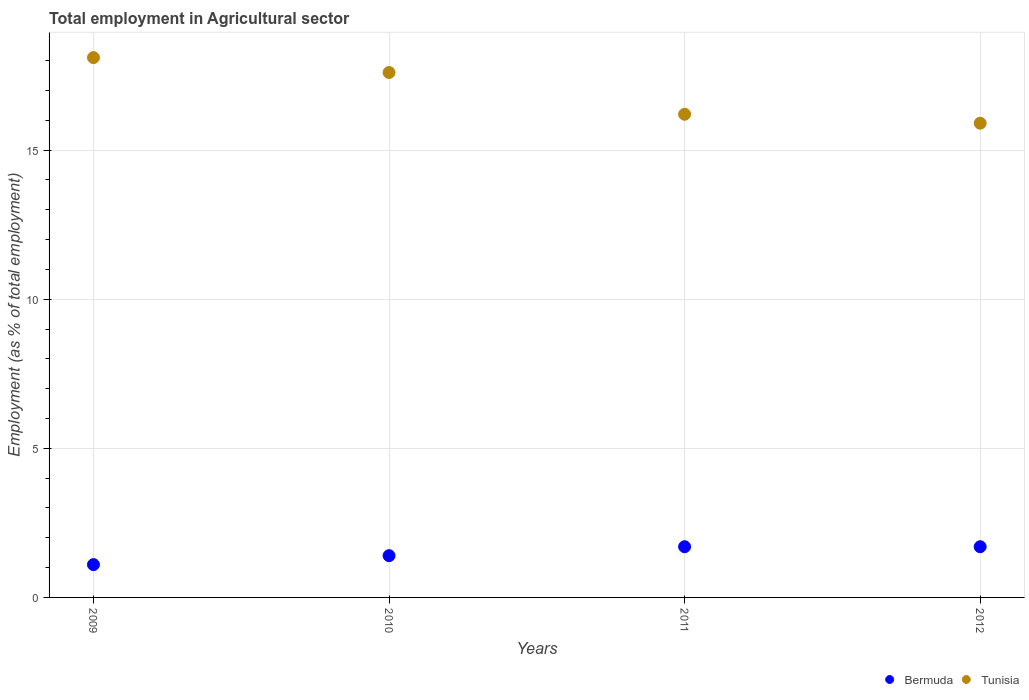How many different coloured dotlines are there?
Provide a short and direct response. 2. Is the number of dotlines equal to the number of legend labels?
Provide a succinct answer. Yes. What is the employment in agricultural sector in Bermuda in 2012?
Offer a very short reply. 1.7. Across all years, what is the maximum employment in agricultural sector in Bermuda?
Give a very brief answer. 1.7. Across all years, what is the minimum employment in agricultural sector in Bermuda?
Your answer should be very brief. 1.1. In which year was the employment in agricultural sector in Bermuda maximum?
Make the answer very short. 2011. What is the total employment in agricultural sector in Bermuda in the graph?
Provide a short and direct response. 5.9. What is the difference between the employment in agricultural sector in Bermuda in 2009 and that in 2010?
Give a very brief answer. -0.3. What is the difference between the employment in agricultural sector in Tunisia in 2011 and the employment in agricultural sector in Bermuda in 2009?
Ensure brevity in your answer.  15.1. What is the average employment in agricultural sector in Bermuda per year?
Provide a succinct answer. 1.48. In the year 2009, what is the difference between the employment in agricultural sector in Tunisia and employment in agricultural sector in Bermuda?
Provide a succinct answer. 17. In how many years, is the employment in agricultural sector in Bermuda greater than 11 %?
Keep it short and to the point. 0. What is the ratio of the employment in agricultural sector in Bermuda in 2009 to that in 2012?
Your answer should be compact. 0.65. Is the employment in agricultural sector in Bermuda in 2009 less than that in 2011?
Your answer should be very brief. Yes. What is the difference between the highest and the lowest employment in agricultural sector in Bermuda?
Your answer should be compact. 0.6. Does the employment in agricultural sector in Bermuda monotonically increase over the years?
Make the answer very short. No. How many dotlines are there?
Provide a succinct answer. 2. How many years are there in the graph?
Ensure brevity in your answer.  4. Where does the legend appear in the graph?
Provide a short and direct response. Bottom right. What is the title of the graph?
Your response must be concise. Total employment in Agricultural sector. Does "Paraguay" appear as one of the legend labels in the graph?
Ensure brevity in your answer.  No. What is the label or title of the X-axis?
Your answer should be compact. Years. What is the label or title of the Y-axis?
Ensure brevity in your answer.  Employment (as % of total employment). What is the Employment (as % of total employment) of Bermuda in 2009?
Your answer should be compact. 1.1. What is the Employment (as % of total employment) in Tunisia in 2009?
Your answer should be very brief. 18.1. What is the Employment (as % of total employment) of Bermuda in 2010?
Provide a succinct answer. 1.4. What is the Employment (as % of total employment) in Tunisia in 2010?
Give a very brief answer. 17.6. What is the Employment (as % of total employment) of Bermuda in 2011?
Offer a very short reply. 1.7. What is the Employment (as % of total employment) in Tunisia in 2011?
Give a very brief answer. 16.2. What is the Employment (as % of total employment) in Bermuda in 2012?
Ensure brevity in your answer.  1.7. What is the Employment (as % of total employment) of Tunisia in 2012?
Offer a very short reply. 15.9. Across all years, what is the maximum Employment (as % of total employment) in Bermuda?
Offer a very short reply. 1.7. Across all years, what is the maximum Employment (as % of total employment) in Tunisia?
Keep it short and to the point. 18.1. Across all years, what is the minimum Employment (as % of total employment) in Bermuda?
Offer a terse response. 1.1. Across all years, what is the minimum Employment (as % of total employment) of Tunisia?
Your response must be concise. 15.9. What is the total Employment (as % of total employment) of Bermuda in the graph?
Keep it short and to the point. 5.9. What is the total Employment (as % of total employment) of Tunisia in the graph?
Keep it short and to the point. 67.8. What is the difference between the Employment (as % of total employment) in Tunisia in 2009 and that in 2010?
Provide a short and direct response. 0.5. What is the difference between the Employment (as % of total employment) of Bermuda in 2009 and that in 2011?
Your answer should be very brief. -0.6. What is the difference between the Employment (as % of total employment) of Tunisia in 2009 and that in 2011?
Your answer should be compact. 1.9. What is the difference between the Employment (as % of total employment) in Tunisia in 2009 and that in 2012?
Your response must be concise. 2.2. What is the difference between the Employment (as % of total employment) of Bermuda in 2010 and that in 2011?
Provide a succinct answer. -0.3. What is the difference between the Employment (as % of total employment) of Tunisia in 2010 and that in 2011?
Ensure brevity in your answer.  1.4. What is the difference between the Employment (as % of total employment) in Bermuda in 2010 and that in 2012?
Ensure brevity in your answer.  -0.3. What is the difference between the Employment (as % of total employment) in Bermuda in 2011 and that in 2012?
Your answer should be compact. 0. What is the difference between the Employment (as % of total employment) of Bermuda in 2009 and the Employment (as % of total employment) of Tunisia in 2010?
Offer a terse response. -16.5. What is the difference between the Employment (as % of total employment) of Bermuda in 2009 and the Employment (as % of total employment) of Tunisia in 2011?
Give a very brief answer. -15.1. What is the difference between the Employment (as % of total employment) in Bermuda in 2009 and the Employment (as % of total employment) in Tunisia in 2012?
Your response must be concise. -14.8. What is the difference between the Employment (as % of total employment) in Bermuda in 2010 and the Employment (as % of total employment) in Tunisia in 2011?
Provide a short and direct response. -14.8. What is the difference between the Employment (as % of total employment) of Bermuda in 2010 and the Employment (as % of total employment) of Tunisia in 2012?
Offer a terse response. -14.5. What is the difference between the Employment (as % of total employment) of Bermuda in 2011 and the Employment (as % of total employment) of Tunisia in 2012?
Your answer should be very brief. -14.2. What is the average Employment (as % of total employment) of Bermuda per year?
Ensure brevity in your answer.  1.48. What is the average Employment (as % of total employment) of Tunisia per year?
Give a very brief answer. 16.95. In the year 2010, what is the difference between the Employment (as % of total employment) in Bermuda and Employment (as % of total employment) in Tunisia?
Offer a terse response. -16.2. In the year 2012, what is the difference between the Employment (as % of total employment) of Bermuda and Employment (as % of total employment) of Tunisia?
Make the answer very short. -14.2. What is the ratio of the Employment (as % of total employment) of Bermuda in 2009 to that in 2010?
Provide a short and direct response. 0.79. What is the ratio of the Employment (as % of total employment) of Tunisia in 2009 to that in 2010?
Make the answer very short. 1.03. What is the ratio of the Employment (as % of total employment) of Bermuda in 2009 to that in 2011?
Offer a very short reply. 0.65. What is the ratio of the Employment (as % of total employment) of Tunisia in 2009 to that in 2011?
Offer a very short reply. 1.12. What is the ratio of the Employment (as % of total employment) of Bermuda in 2009 to that in 2012?
Keep it short and to the point. 0.65. What is the ratio of the Employment (as % of total employment) of Tunisia in 2009 to that in 2012?
Offer a terse response. 1.14. What is the ratio of the Employment (as % of total employment) of Bermuda in 2010 to that in 2011?
Make the answer very short. 0.82. What is the ratio of the Employment (as % of total employment) in Tunisia in 2010 to that in 2011?
Ensure brevity in your answer.  1.09. What is the ratio of the Employment (as % of total employment) in Bermuda in 2010 to that in 2012?
Provide a succinct answer. 0.82. What is the ratio of the Employment (as % of total employment) of Tunisia in 2010 to that in 2012?
Provide a short and direct response. 1.11. What is the ratio of the Employment (as % of total employment) of Tunisia in 2011 to that in 2012?
Your answer should be very brief. 1.02. What is the difference between the highest and the second highest Employment (as % of total employment) of Tunisia?
Your answer should be compact. 0.5. What is the difference between the highest and the lowest Employment (as % of total employment) of Bermuda?
Provide a short and direct response. 0.6. 